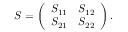<formula> <loc_0><loc_0><loc_500><loc_500>S = \left ( \begin{array} { l l } { S _ { 1 1 } } & { S _ { 1 2 } } \\ { S _ { 2 1 } } & { S _ { 2 2 } } \end{array} \right ) .</formula> 